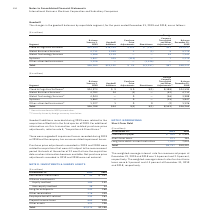According to International Business Machines's financial document, What was the weighted average interest rate for commercial paper at December 31, 2019? According to the financial document, 1.6 percent. The relevant text states: "ommercial paper at December 31, 2019 and 2018 was 1.6 percent and 2.5 percent, respectively. The weighted-average interest rates for short-term loans were 6.1 pe..." Also, What was the commercial paper in 2018? According to the financial document, $ 2,995 (in millions). The relevant text states: "Commercial paper $ 304 $ 2,995..." Also, can you calculate: What was the increase / (decrease) in the short term loan from 2018 to 2019? Based on the calculation: 971 - 161, the result is 810 (in millions). This is based on the information: "Short-term loans 971 161 Short-term loans 971 161..." The key data points involved are: 161, 971. Also, can you calculate: What was the average Long-term debt—current maturities? To answer this question, I need to perform calculations using the financial data. The calculation is: (7,522 + 7,051) / 2, which equals 7286.5 (in millions). This is based on the information: "Long-term debt—current maturities 7,522 7,051 Long-term debt—current maturities 7,522 7,051..." The key data points involved are: 7,051, 7,522. Also, can you calculate: What was the percentage increase / (decrease) in total short term debt? To answer this question, I need to perform calculations using the financial data. The calculation is: 8,797 / 10,207 - 1, which equals -13.81 (percentage). This is based on the information: "Total $8,797 $10,207 Total $8,797 $10,207..." The key data points involved are: 10,207, 8,797. Also, What was the weighted average interest rate for short-term loans at December 31, 2019? According to the financial document, 6.1 percent. The relevant text states: "-average interest rates for short-term loans were 6.1 percent and 4.3 percent at December 31, 2019 and 2018, respectively...." 